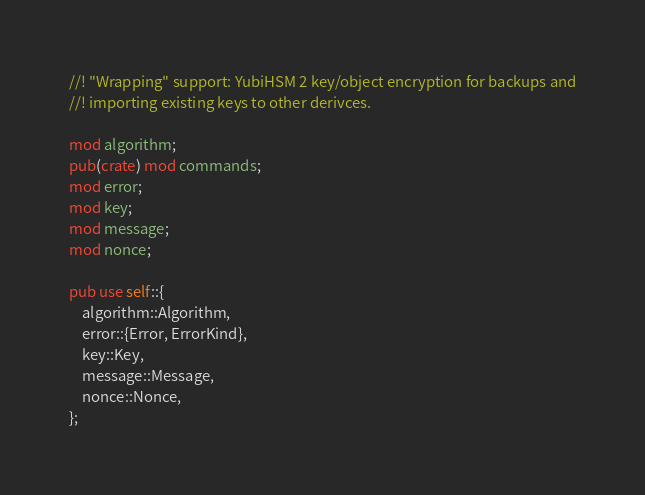<code> <loc_0><loc_0><loc_500><loc_500><_Rust_>//! "Wrapping" support: YubiHSM 2 key/object encryption for backups and
//! importing existing keys to other derivces.

mod algorithm;
pub(crate) mod commands;
mod error;
mod key;
mod message;
mod nonce;

pub use self::{
    algorithm::Algorithm,
    error::{Error, ErrorKind},
    key::Key,
    message::Message,
    nonce::Nonce,
};
</code> 